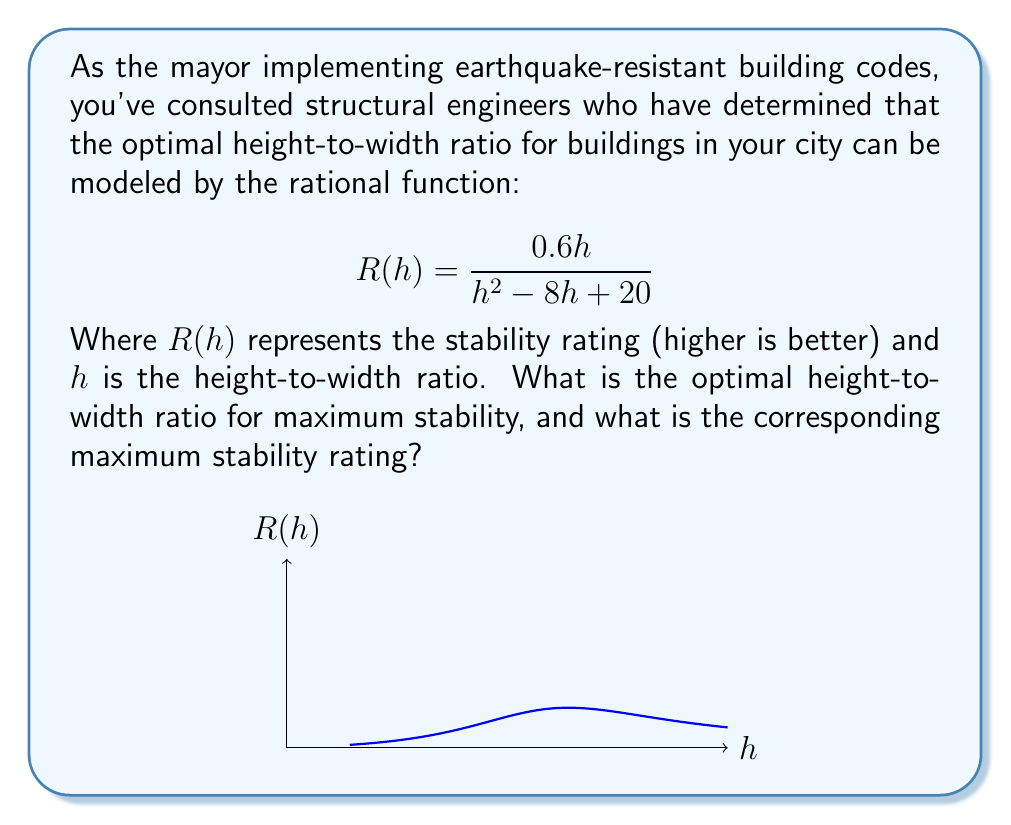Provide a solution to this math problem. To find the optimal height-to-width ratio, we need to determine the maximum value of the rational function $R(h)$. Here's how we can do this:

1) First, let's find the critical points by taking the derivative of $R(h)$ and setting it equal to zero:

   $$R'(h) = \frac{(0.6)(h^2 - 8h + 20) - 0.6h(2h - 8)}{(h^2 - 8h + 20)^2} = 0$$

2) Simplify the numerator:
   
   $$0.6h^2 - 4.8h + 12 - 1.2h^2 + 4.8h = 0$$
   $$-0.6h^2 + 12 = 0$$

3) Solve for h:
   
   $$h^2 = 20$$
   $$h = \sqrt{20} = 2\sqrt{5} \approx 4.47$$

4) To confirm this is a maximum, we can check the second derivative or observe the behavior of the function.

5) Now, let's calculate the maximum stability rating by plugging this h-value back into our original function:

   $$R(2\sqrt{5}) = \frac{0.6(2\sqrt{5})}{(2\sqrt{5})^2 - 8(2\sqrt{5}) + 20}$$
   
   $$= \frac{1.2\sqrt{5}}{20 - 16\sqrt{5} + 20} = \frac{1.2\sqrt{5}}{40 - 16\sqrt{5}}$$

   $$= \frac{1.2\sqrt{5}(40 + 16\sqrt{5})}{(40 - 16\sqrt{5})(40 + 16\sqrt{5})} = \frac{48\sqrt{5} + 96}{1600 - 256(5)} = \frac{48\sqrt{5} + 96}{320} = \frac{3\sqrt{5} + 6}{20}$$

Thus, the optimal height-to-width ratio is $2\sqrt{5}$, and the maximum stability rating is $\frac{3\sqrt{5} + 6}{20}$.
Answer: Optimal ratio: $2\sqrt{5}$; Maximum stability: $\frac{3\sqrt{5} + 6}{20}$ 